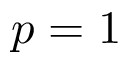<formula> <loc_0><loc_0><loc_500><loc_500>p = 1</formula> 